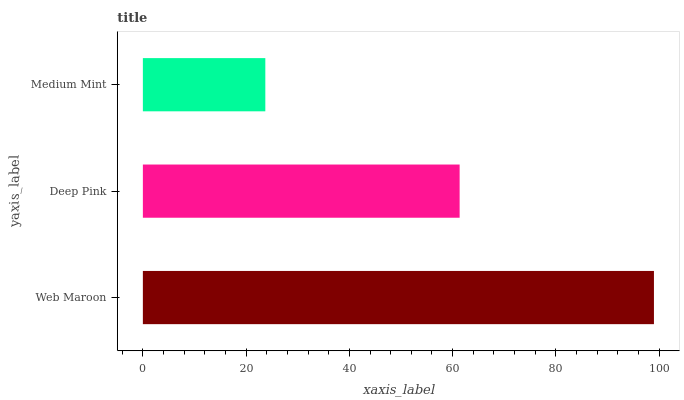Is Medium Mint the minimum?
Answer yes or no. Yes. Is Web Maroon the maximum?
Answer yes or no. Yes. Is Deep Pink the minimum?
Answer yes or no. No. Is Deep Pink the maximum?
Answer yes or no. No. Is Web Maroon greater than Deep Pink?
Answer yes or no. Yes. Is Deep Pink less than Web Maroon?
Answer yes or no. Yes. Is Deep Pink greater than Web Maroon?
Answer yes or no. No. Is Web Maroon less than Deep Pink?
Answer yes or no. No. Is Deep Pink the high median?
Answer yes or no. Yes. Is Deep Pink the low median?
Answer yes or no. Yes. Is Web Maroon the high median?
Answer yes or no. No. Is Web Maroon the low median?
Answer yes or no. No. 